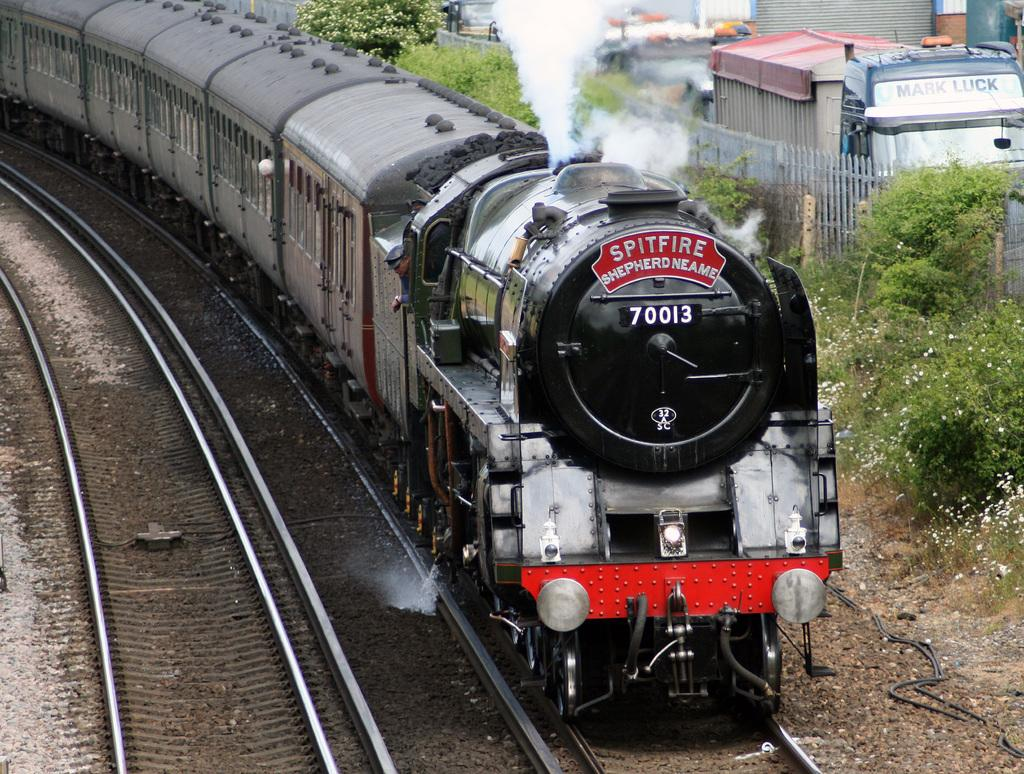<image>
Render a clear and concise summary of the photo. A train called the Spitfire is letting some steam out of the top. 